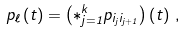Convert formula to latex. <formula><loc_0><loc_0><loc_500><loc_500>p _ { \ell } \left ( t \right ) = \left ( \ast _ { j = 1 } ^ { k } p _ { i _ { j } i _ { j + 1 } } \right ) \left ( t \right ) \, ,</formula> 